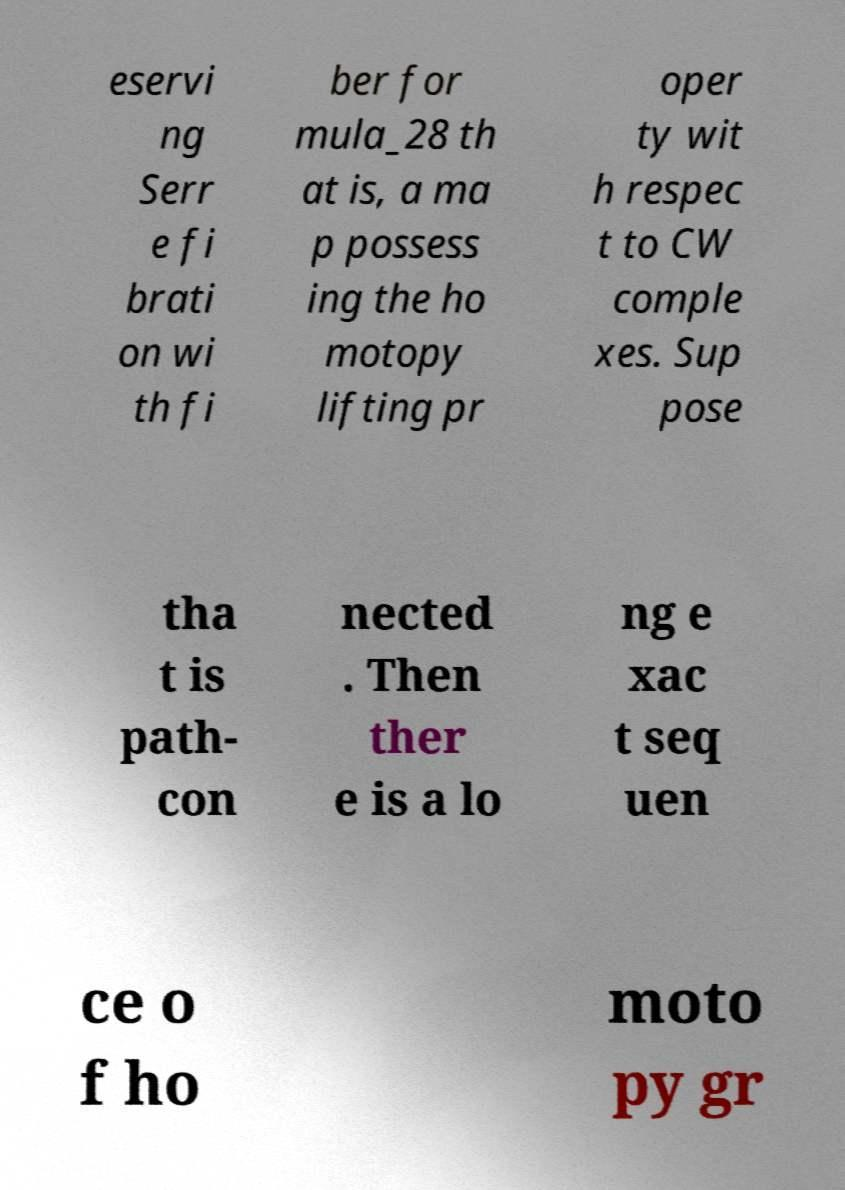Can you accurately transcribe the text from the provided image for me? eservi ng Serr e fi brati on wi th fi ber for mula_28 th at is, a ma p possess ing the ho motopy lifting pr oper ty wit h respec t to CW comple xes. Sup pose tha t is path- con nected . Then ther e is a lo ng e xac t seq uen ce o f ho moto py gr 